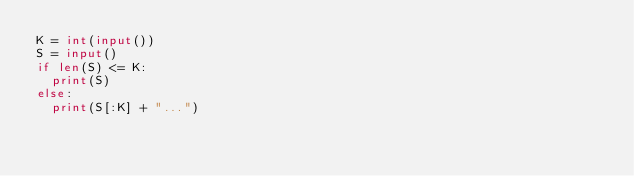<code> <loc_0><loc_0><loc_500><loc_500><_Python_>K = int(input())
S = input()
if len(S) <= K:
  print(S)
else:
  print(S[:K] + "...")
</code> 